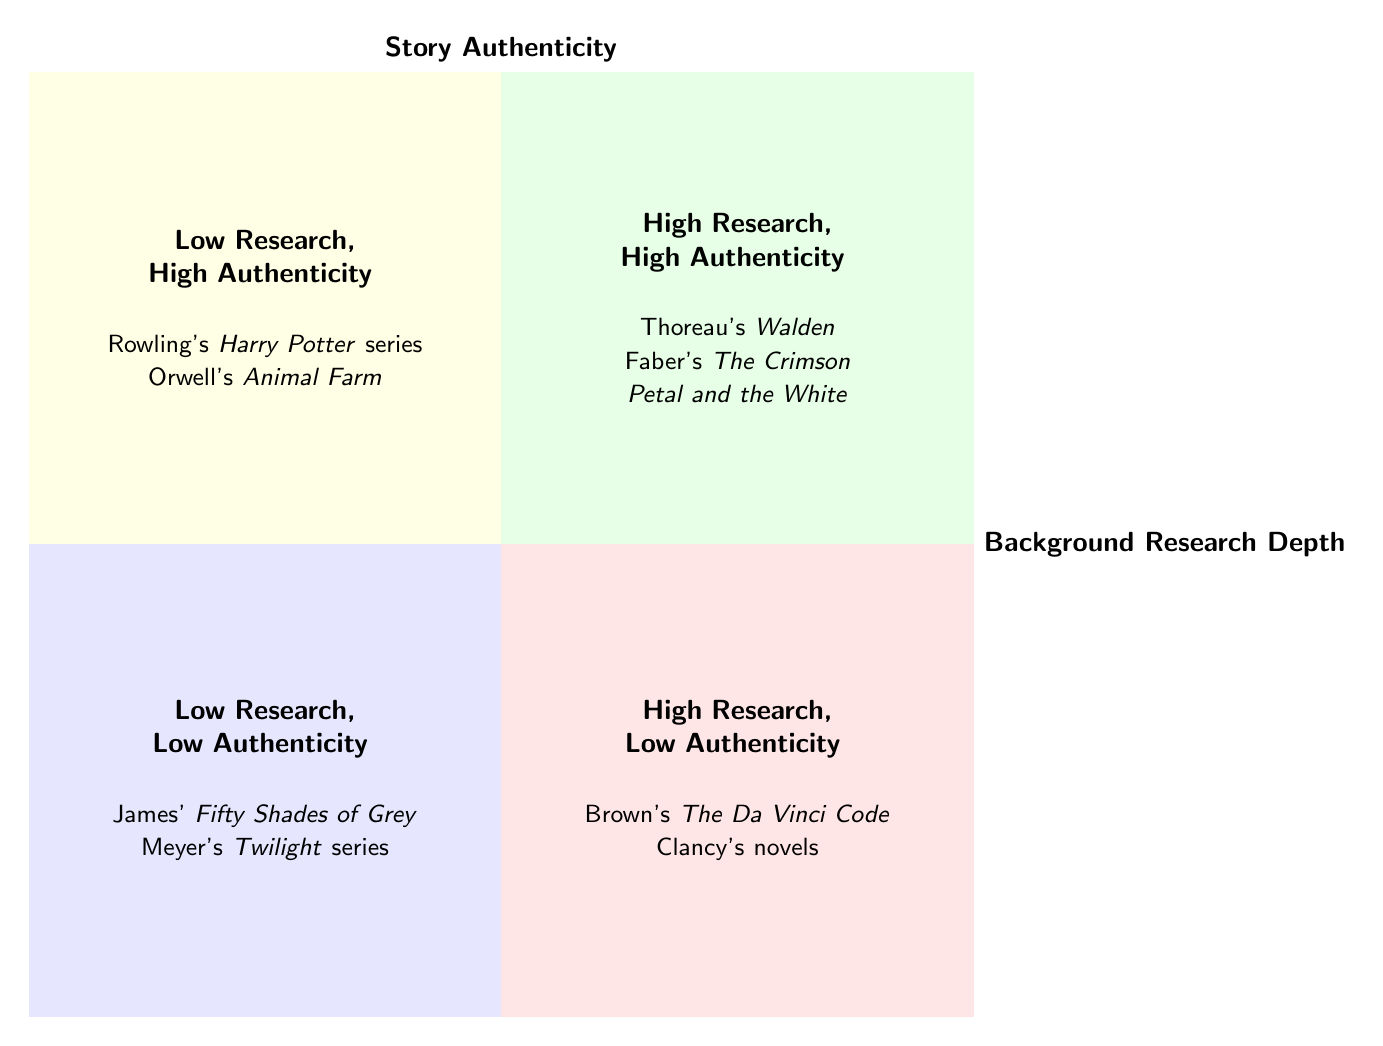What are the titles in the High Research, High Authenticity quadrant? The titles listed under the High Research, High Authenticity quadrant are specifically Thoreau's "Walden" and Faber's "The Crimson Petal and the White."
Answer: "Walden" and "The Crimson Petal and the White" Which quadrant contains E. L. James' Fifty Shades of Grey? E. L. James' "Fifty Shades of Grey" is located in the Low Research, Low Authenticity quadrant according to the diagram.
Answer: Low Research, Low Authenticity How many titles are in the Low Research, High Authenticity quadrant? The Low Research, High Authenticity quadrant includes two titles: Rowling's "Harry Potter" series and Orwell's "Animal Farm," so the total is two.
Answer: 2 Which author has works in the High Research, Low Authenticity quadrant? Dan Brown is the author whose work, "The Da Vinci Code," is found in the High Research, Low Authenticity quadrant.
Answer: Dan Brown Are there any authors in both the High Research quadrants? No authors are noted in both High Research quadrants as they have distinct categorization: High Research, High Authenticity or High Research, Low Authenticity without overlap.
Answer: No 